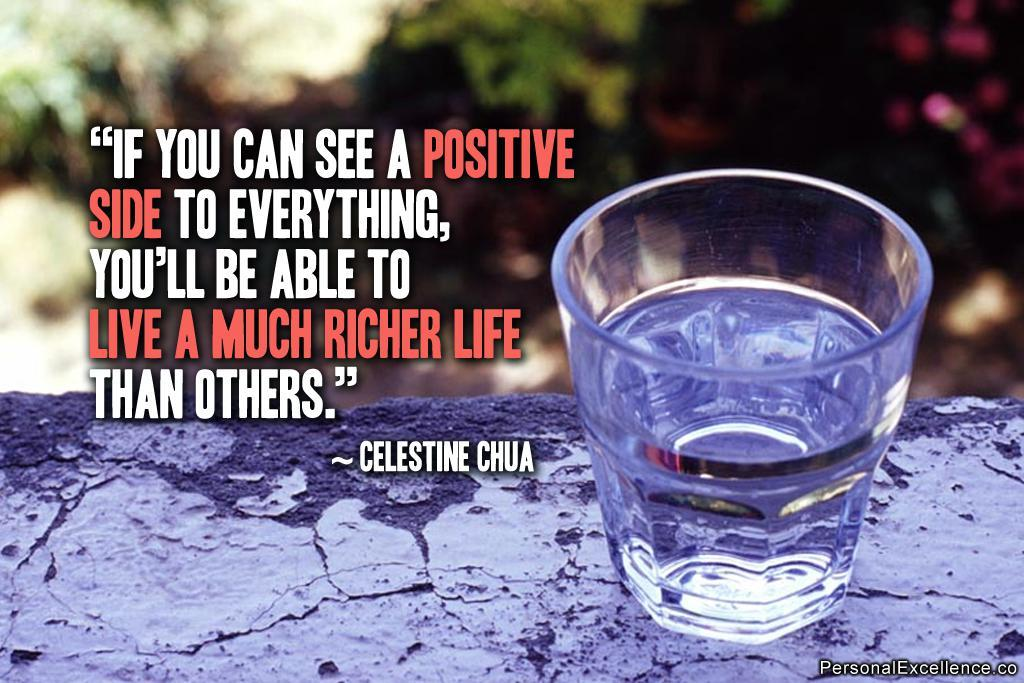<image>
Give a short and clear explanation of the subsequent image. A glass of water sitting on some concrete with a quote by Celestine Chua next to it. 